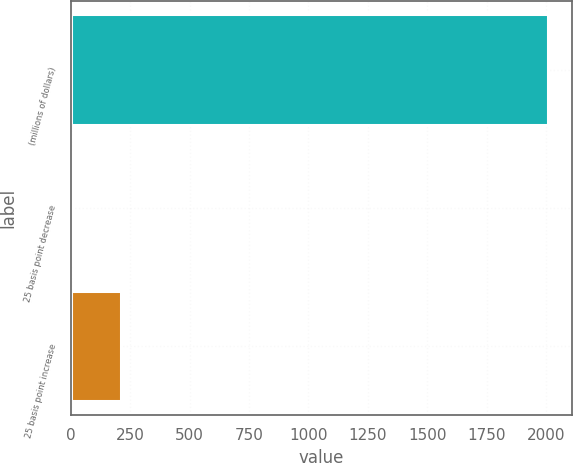Convert chart. <chart><loc_0><loc_0><loc_500><loc_500><bar_chart><fcel>(millions of dollars)<fcel>25 basis point decrease<fcel>25 basis point increase<nl><fcel>2009<fcel>9.9<fcel>209.81<nl></chart> 